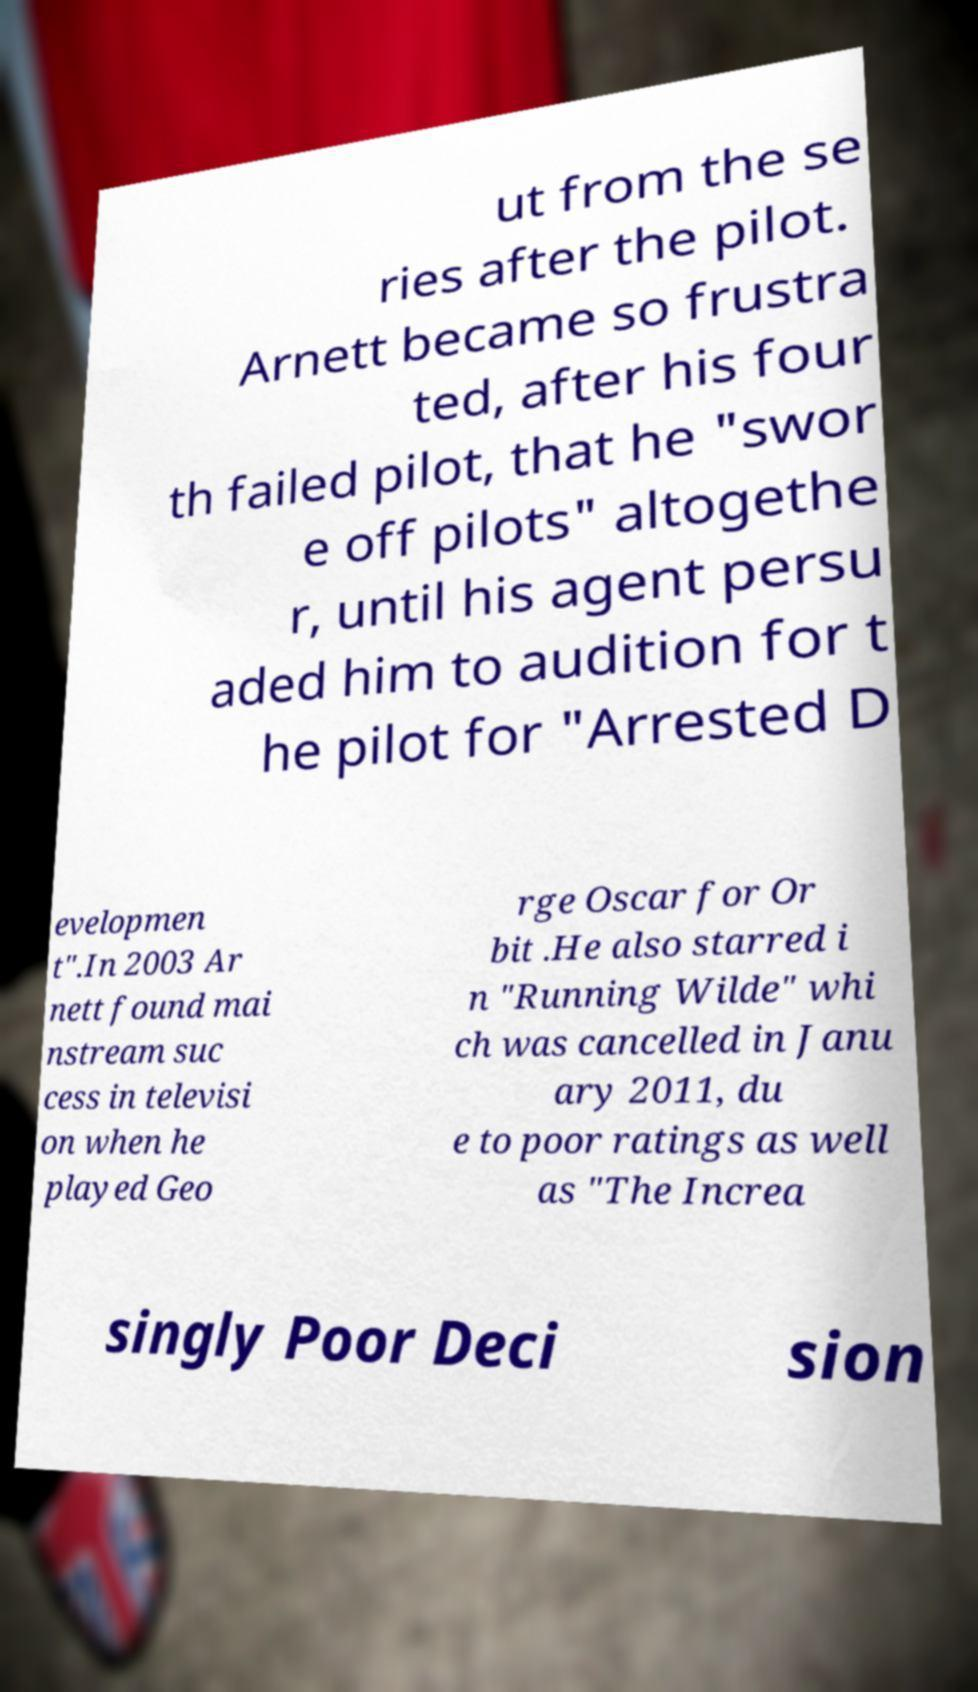Please read and relay the text visible in this image. What does it say? ut from the se ries after the pilot. Arnett became so frustra ted, after his four th failed pilot, that he "swor e off pilots" altogethe r, until his agent persu aded him to audition for t he pilot for "Arrested D evelopmen t".In 2003 Ar nett found mai nstream suc cess in televisi on when he played Geo rge Oscar for Or bit .He also starred i n "Running Wilde" whi ch was cancelled in Janu ary 2011, du e to poor ratings as well as "The Increa singly Poor Deci sion 